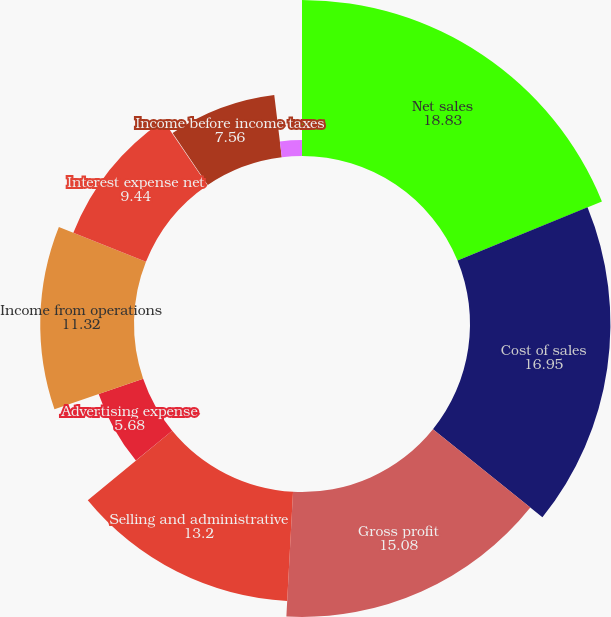Convert chart to OTSL. <chart><loc_0><loc_0><loc_500><loc_500><pie_chart><fcel>Net sales<fcel>Cost of sales<fcel>Gross profit<fcel>Selling and administrative<fcel>Advertising expense<fcel>Income from operations<fcel>Interest expense net<fcel>Net loss on extinguishments of<fcel>Income before income taxes<fcel>Income tax expense<nl><fcel>18.83%<fcel>16.95%<fcel>15.08%<fcel>13.2%<fcel>5.68%<fcel>11.32%<fcel>9.44%<fcel>0.04%<fcel>7.56%<fcel>1.92%<nl></chart> 